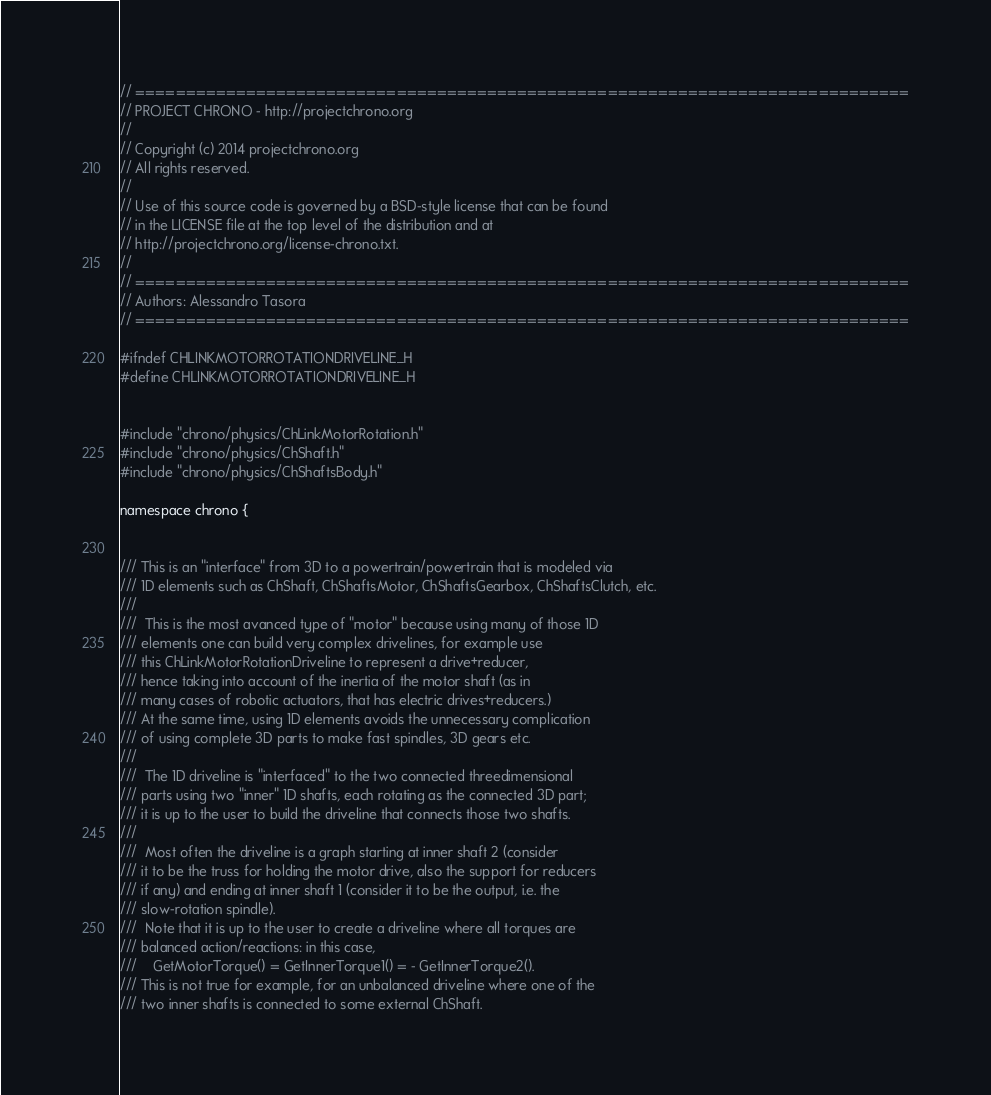<code> <loc_0><loc_0><loc_500><loc_500><_C_>// =============================================================================
// PROJECT CHRONO - http://projectchrono.org
//
// Copyright (c) 2014 projectchrono.org
// All rights reserved.
//
// Use of this source code is governed by a BSD-style license that can be found
// in the LICENSE file at the top level of the distribution and at
// http://projectchrono.org/license-chrono.txt.
//
// =============================================================================
// Authors: Alessandro Tasora
// =============================================================================

#ifndef CHLINKMOTORROTATIONDRIVELINE_H
#define CHLINKMOTORROTATIONDRIVELINE_H


#include "chrono/physics/ChLinkMotorRotation.h"
#include "chrono/physics/ChShaft.h"
#include "chrono/physics/ChShaftsBody.h"

namespace chrono {


/// This is an "interface" from 3D to a powertrain/powertrain that is modeled via
/// 1D elements such as ChShaft, ChShaftsMotor, ChShaftsGearbox, ChShaftsClutch, etc. 
///
///  This is the most avanced type of "motor" because using many of those 1D
/// elements one can build very complex drivelines, for example use
/// this ChLinkMotorRotationDriveline to represent a drive+reducer,
/// hence taking into account of the inertia of the motor shaft (as in
/// many cases of robotic actuators, that has electric drives+reducers.)
/// At the same time, using 1D elements avoids the unnecessary complication 
/// of using complete 3D parts to make fast spindles, 3D gears etc. 
///
///  The 1D driveline is "interfaced" to the two connected threedimensional
/// parts using two "inner" 1D shafts, each rotating as the connected 3D part;
/// it is up to the user to build the driveline that connects those two shafts.
///
///  Most often the driveline is a graph starting at inner shaft 2 (consider 
/// it to be the truss for holding the motor drive, also the support for reducers 
/// if any) and ending at inner shaft 1 (consider it to be the output, i.e. the 
/// slow-rotation spindle).
///  Note that it is up to the user to create a driveline where all torques are
/// balanced action/reactions: in this case, 
///    GetMotorTorque() = GetInnerTorque1() = - GetInnerTorque2(). 
/// This is not true for example, for an unbalanced driveline where one of the 
/// two inner shafts is connected to some external ChShaft. 
</code> 